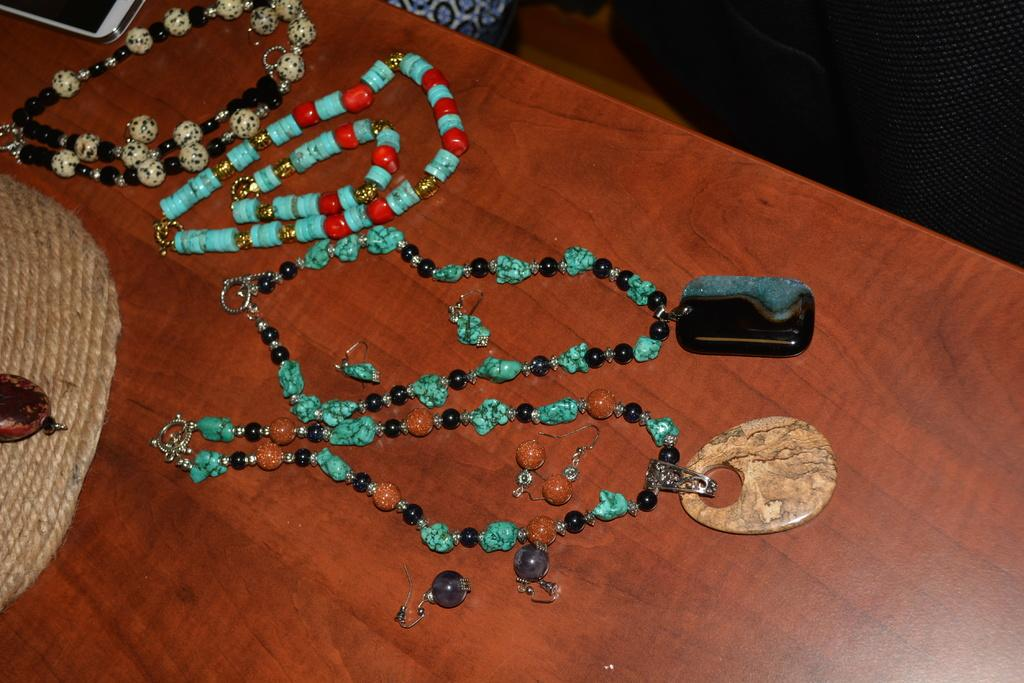What type of objects are on the wooden table in the image? There are bead chains on the wooden table. Is there anything else on the wooden table besides the bead chains? Yes, there is an object on the wooden table. What can be observed about the background of the image? The background of the image is dark in color. How does the ice interact with the bead chains in the image? There is no ice present in the image, so it cannot interact with the bead chains. 